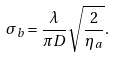Convert formula to latex. <formula><loc_0><loc_0><loc_500><loc_500>\sigma _ { b } = \frac { \lambda } { \pi D } \sqrt { \frac { 2 } { \eta _ { a } } } .</formula> 